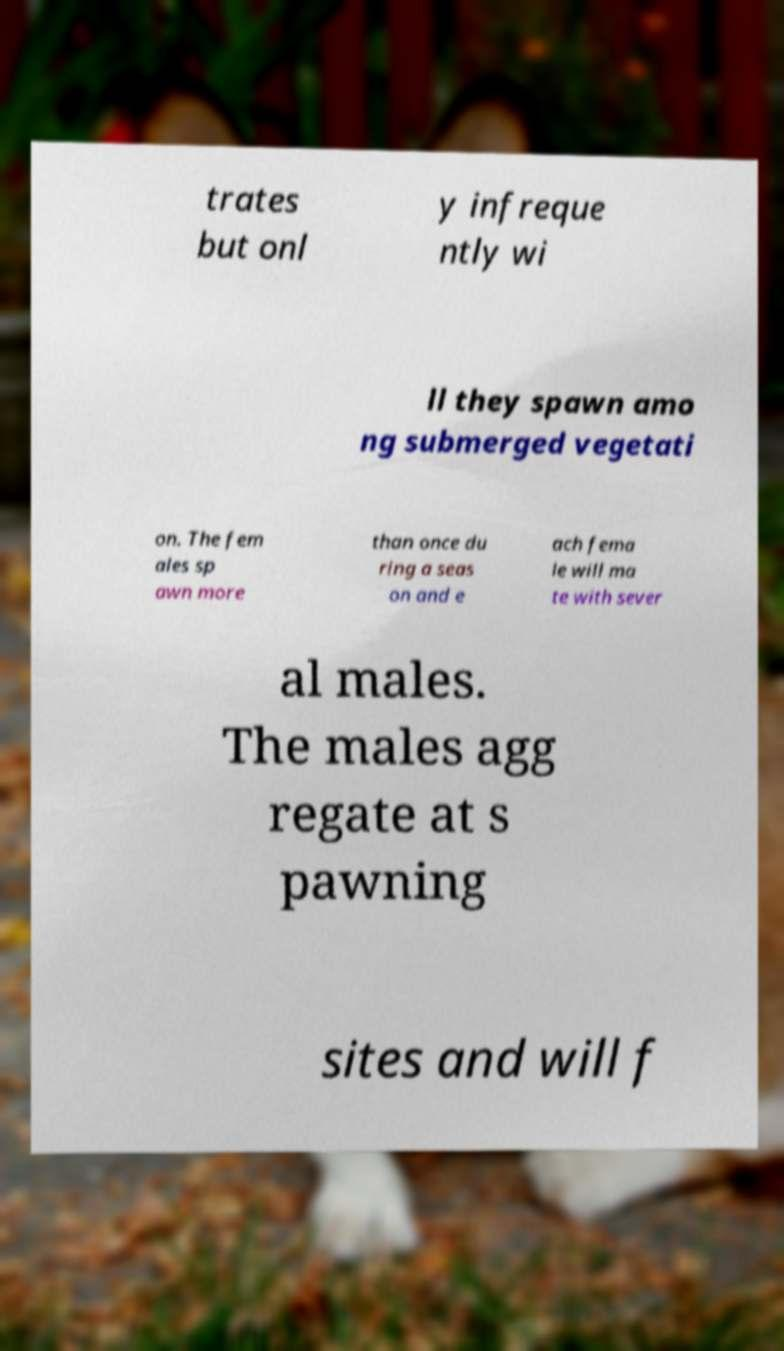Please read and relay the text visible in this image. What does it say? trates but onl y infreque ntly wi ll they spawn amo ng submerged vegetati on. The fem ales sp awn more than once du ring a seas on and e ach fema le will ma te with sever al males. The males agg regate at s pawning sites and will f 